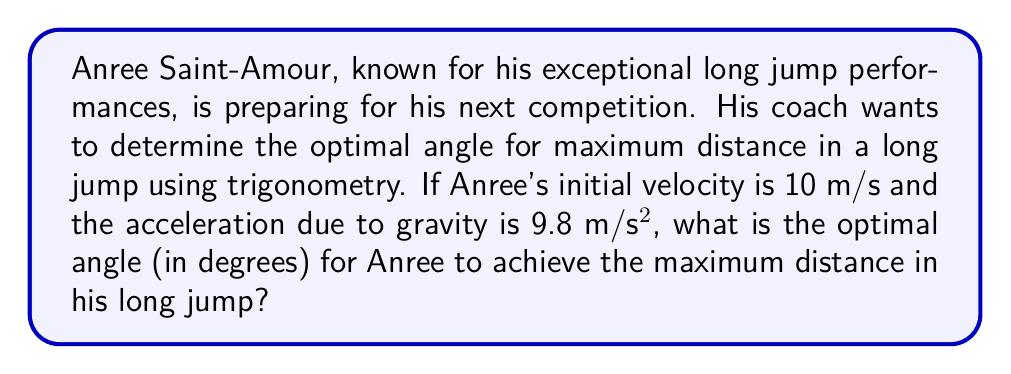Give your solution to this math problem. To solve this problem, we'll use the principles of projectile motion and trigonometry. The optimal angle for maximum distance in a long jump is 45° for ideal conditions. However, we'll prove this mathematically:

1) The horizontal distance (d) traveled by a projectile (in this case, Anree during his long jump) is given by the equation:

   $$ d = \frac{v_0^2 \sin(2\theta)}{g} $$

   Where:
   $v_0$ is the initial velocity
   $\theta$ is the angle of projection
   $g$ is the acceleration due to gravity

2) To find the maximum distance, we need to maximize $\sin(2\theta)$. The maximum value of sine is 1, which occurs when its argument is 90°.

3) So, we want:

   $$ 2\theta = 90° $$

4) Solving for $\theta$:

   $$ \theta = 45° $$

5) We can verify this by calculating the distance for angles slightly above and below 45°:

   For $\theta = 44°$:
   $$ d = \frac{10^2 \sin(2(44°))}{9.8} \approx 10.18 \text{ m} $$

   For $\theta = 45°$:
   $$ d = \frac{10^2 \sin(2(45°))}{9.8} \approx 10.20 \text{ m} $$

   For $\theta = 46°$:
   $$ d = \frac{10^2 \sin(2(46°))}{9.8} \approx 10.18 \text{ m} $$

This confirms that 45° gives the maximum distance.
Answer: The optimal angle for Anree Saint-Amour to achieve maximum distance in his long jump is 45°. 